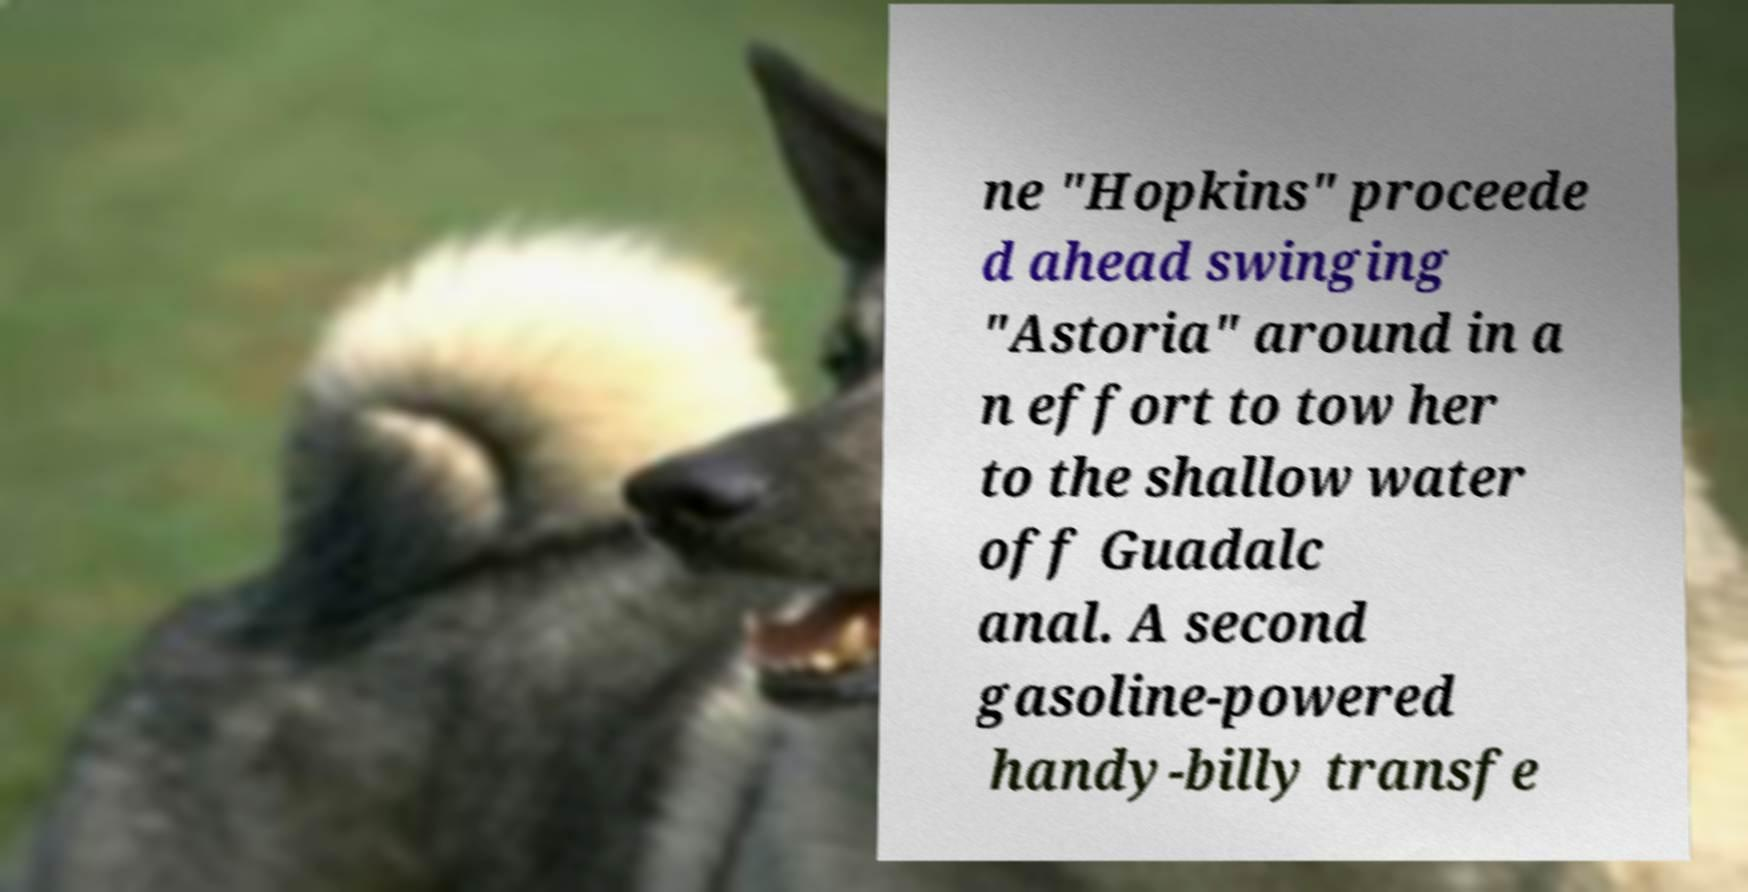Could you extract and type out the text from this image? ne "Hopkins" proceede d ahead swinging "Astoria" around in a n effort to tow her to the shallow water off Guadalc anal. A second gasoline-powered handy-billy transfe 